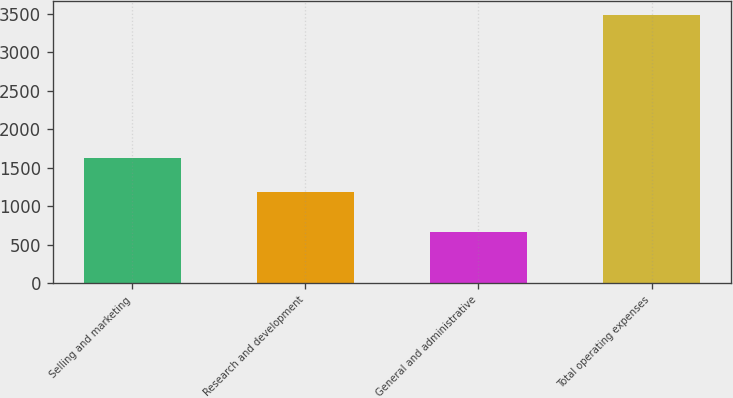Convert chart. <chart><loc_0><loc_0><loc_500><loc_500><bar_chart><fcel>Selling and marketing<fcel>Research and development<fcel>General and administrative<fcel>Total operating expenses<nl><fcel>1634<fcel>1186<fcel>664<fcel>3490<nl></chart> 